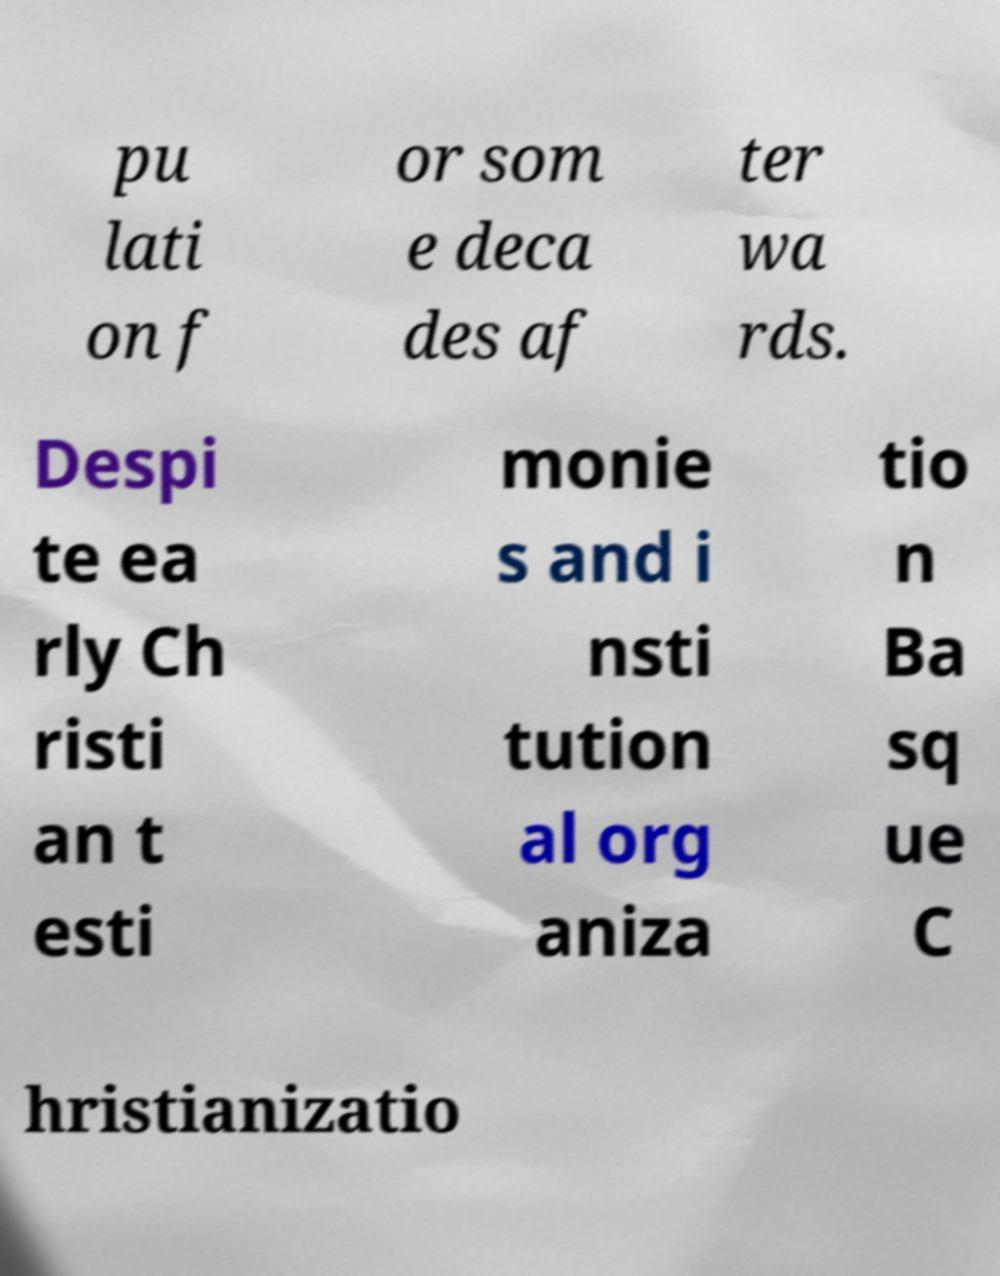What messages or text are displayed in this image? I need them in a readable, typed format. pu lati on f or som e deca des af ter wa rds. Despi te ea rly Ch risti an t esti monie s and i nsti tution al org aniza tio n Ba sq ue C hristianizatio 